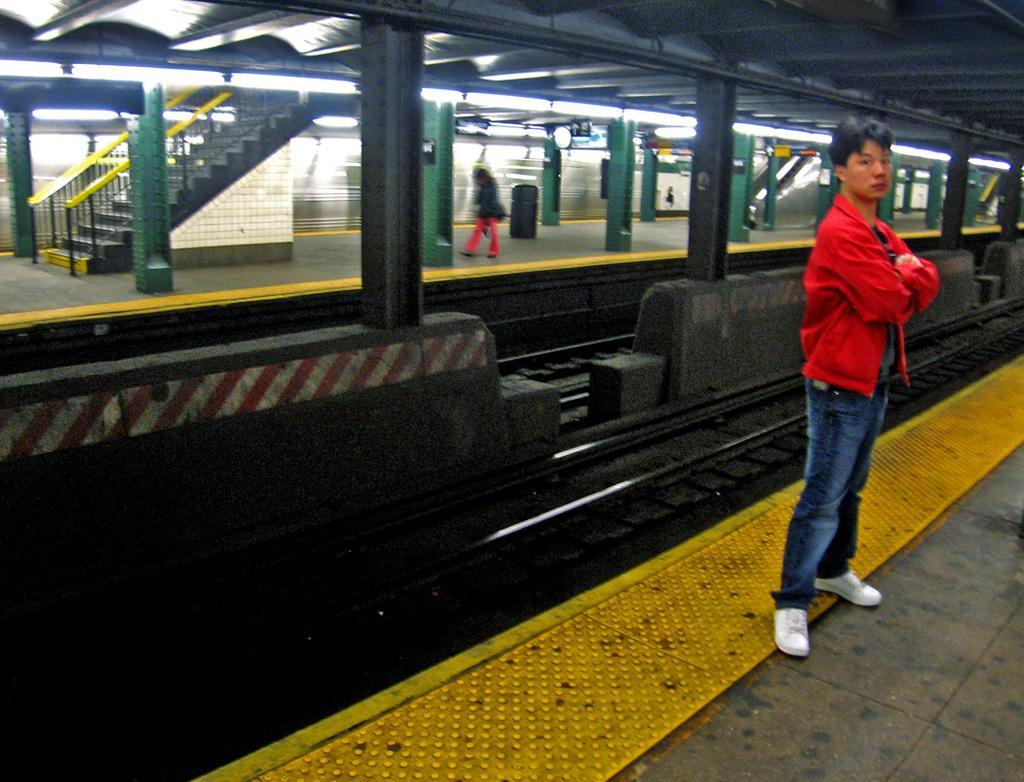How would you summarize this image in a sentence or two? In this image I can see a person standing on the platform, behind him there are few tracks also there is another platform. 